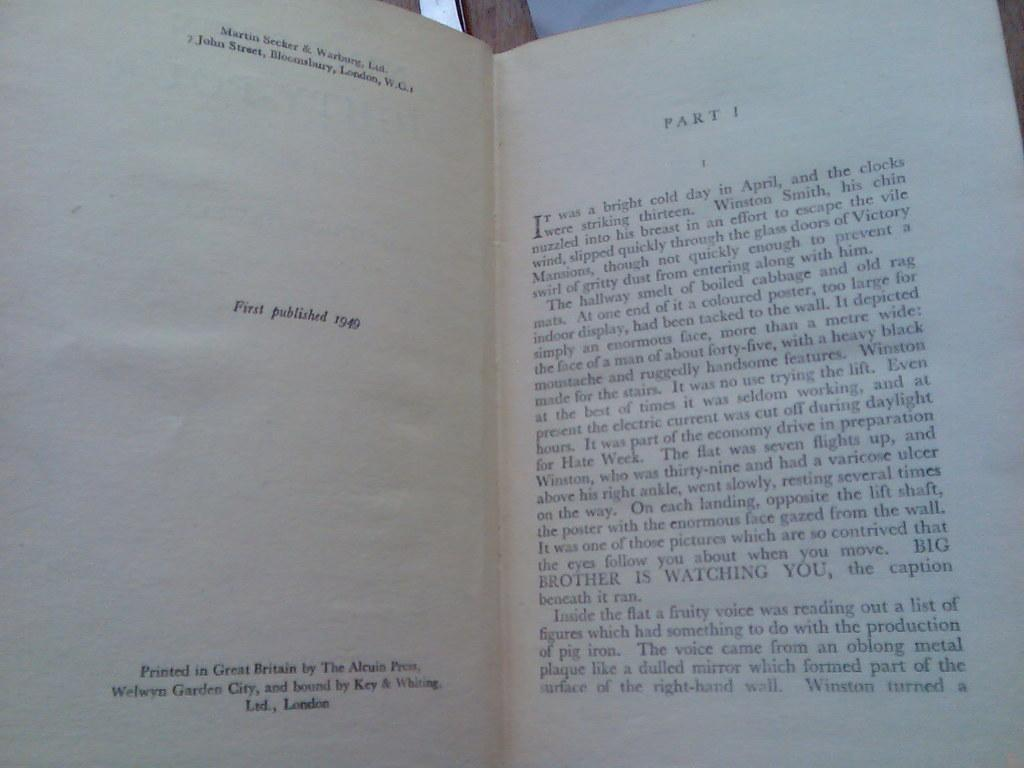Provide a one-sentence caption for the provided image. A book first published in 1949 is shown opened to part one. 